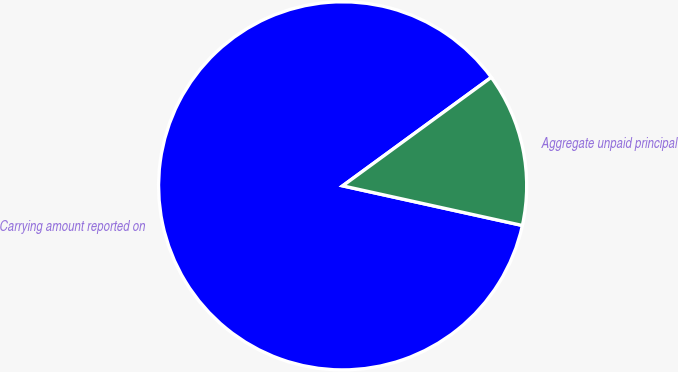Convert chart. <chart><loc_0><loc_0><loc_500><loc_500><pie_chart><fcel>Carrying amount reported on<fcel>Aggregate unpaid principal<nl><fcel>86.51%<fcel>13.49%<nl></chart> 